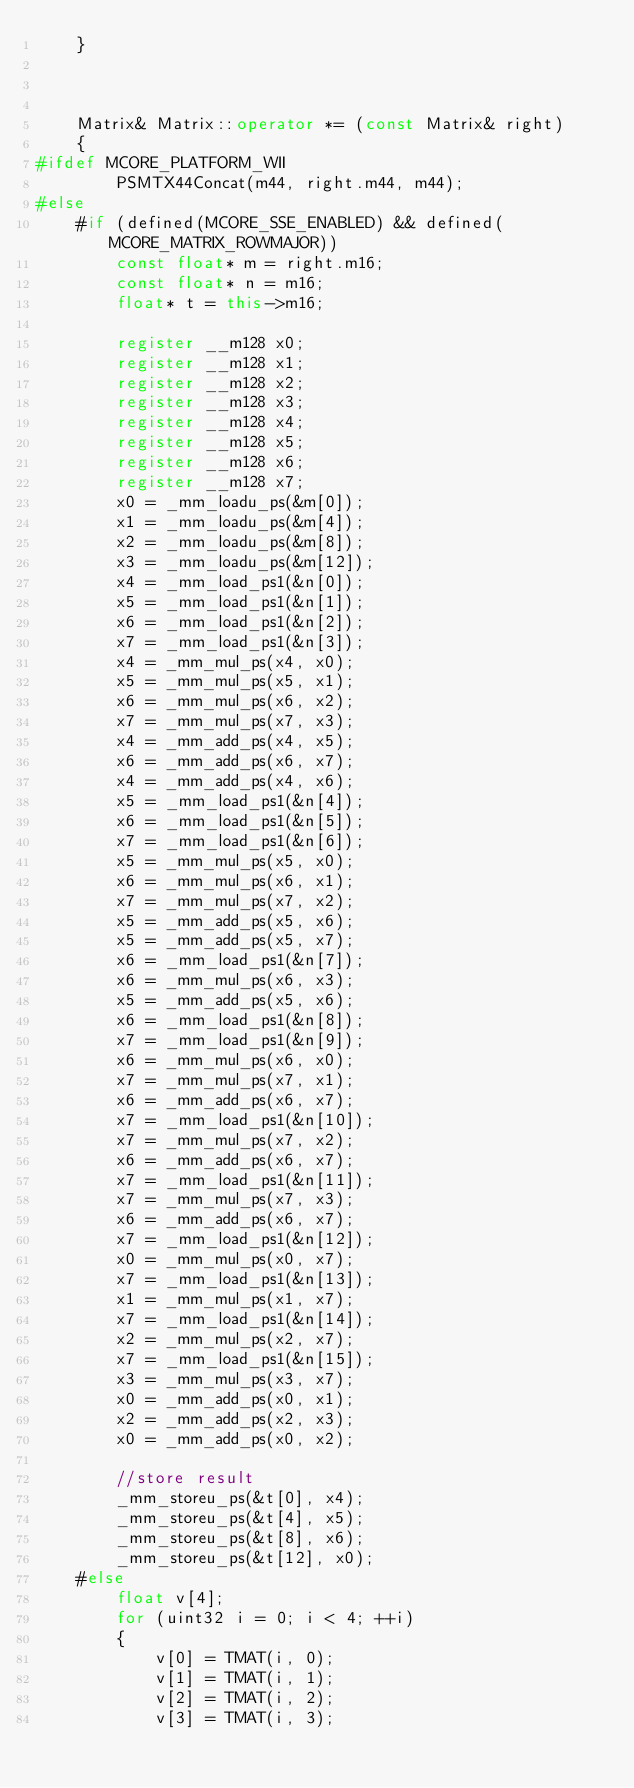Convert code to text. <code><loc_0><loc_0><loc_500><loc_500><_C++_>    }



    Matrix& Matrix::operator *= (const Matrix& right)
    {
#ifdef MCORE_PLATFORM_WII
        PSMTX44Concat(m44, right.m44, m44);
#else
    #if (defined(MCORE_SSE_ENABLED) && defined(MCORE_MATRIX_ROWMAJOR))
        const float* m = right.m16;
        const float* n = m16;
        float* t = this->m16;

        register __m128 x0;
        register __m128 x1;
        register __m128 x2;
        register __m128 x3;
        register __m128 x4;
        register __m128 x5;
        register __m128 x6;
        register __m128 x7;
        x0 = _mm_loadu_ps(&m[0]);
        x1 = _mm_loadu_ps(&m[4]);
        x2 = _mm_loadu_ps(&m[8]);
        x3 = _mm_loadu_ps(&m[12]);
        x4 = _mm_load_ps1(&n[0]);
        x5 = _mm_load_ps1(&n[1]);
        x6 = _mm_load_ps1(&n[2]);
        x7 = _mm_load_ps1(&n[3]);
        x4 = _mm_mul_ps(x4, x0);
        x5 = _mm_mul_ps(x5, x1);
        x6 = _mm_mul_ps(x6, x2);
        x7 = _mm_mul_ps(x7, x3);
        x4 = _mm_add_ps(x4, x5);
        x6 = _mm_add_ps(x6, x7);
        x4 = _mm_add_ps(x4, x6);
        x5 = _mm_load_ps1(&n[4]);
        x6 = _mm_load_ps1(&n[5]);
        x7 = _mm_load_ps1(&n[6]);
        x5 = _mm_mul_ps(x5, x0);
        x6 = _mm_mul_ps(x6, x1);
        x7 = _mm_mul_ps(x7, x2);
        x5 = _mm_add_ps(x5, x6);
        x5 = _mm_add_ps(x5, x7);
        x6 = _mm_load_ps1(&n[7]);
        x6 = _mm_mul_ps(x6, x3);
        x5 = _mm_add_ps(x5, x6);
        x6 = _mm_load_ps1(&n[8]);
        x7 = _mm_load_ps1(&n[9]);
        x6 = _mm_mul_ps(x6, x0);
        x7 = _mm_mul_ps(x7, x1);
        x6 = _mm_add_ps(x6, x7);
        x7 = _mm_load_ps1(&n[10]);
        x7 = _mm_mul_ps(x7, x2);
        x6 = _mm_add_ps(x6, x7);
        x7 = _mm_load_ps1(&n[11]);
        x7 = _mm_mul_ps(x7, x3);
        x6 = _mm_add_ps(x6, x7);
        x7 = _mm_load_ps1(&n[12]);
        x0 = _mm_mul_ps(x0, x7);
        x7 = _mm_load_ps1(&n[13]);
        x1 = _mm_mul_ps(x1, x7);
        x7 = _mm_load_ps1(&n[14]);
        x2 = _mm_mul_ps(x2, x7);
        x7 = _mm_load_ps1(&n[15]);
        x3 = _mm_mul_ps(x3, x7);
        x0 = _mm_add_ps(x0, x1);
        x2 = _mm_add_ps(x2, x3);
        x0 = _mm_add_ps(x0, x2);

        //store result
        _mm_storeu_ps(&t[0], x4);
        _mm_storeu_ps(&t[4], x5);
        _mm_storeu_ps(&t[8], x6);
        _mm_storeu_ps(&t[12], x0);
    #else
        float v[4];
        for (uint32 i = 0; i < 4; ++i)
        {
            v[0] = TMAT(i, 0);
            v[1] = TMAT(i, 1);
            v[2] = TMAT(i, 2);
            v[3] = TMAT(i, 3);</code> 